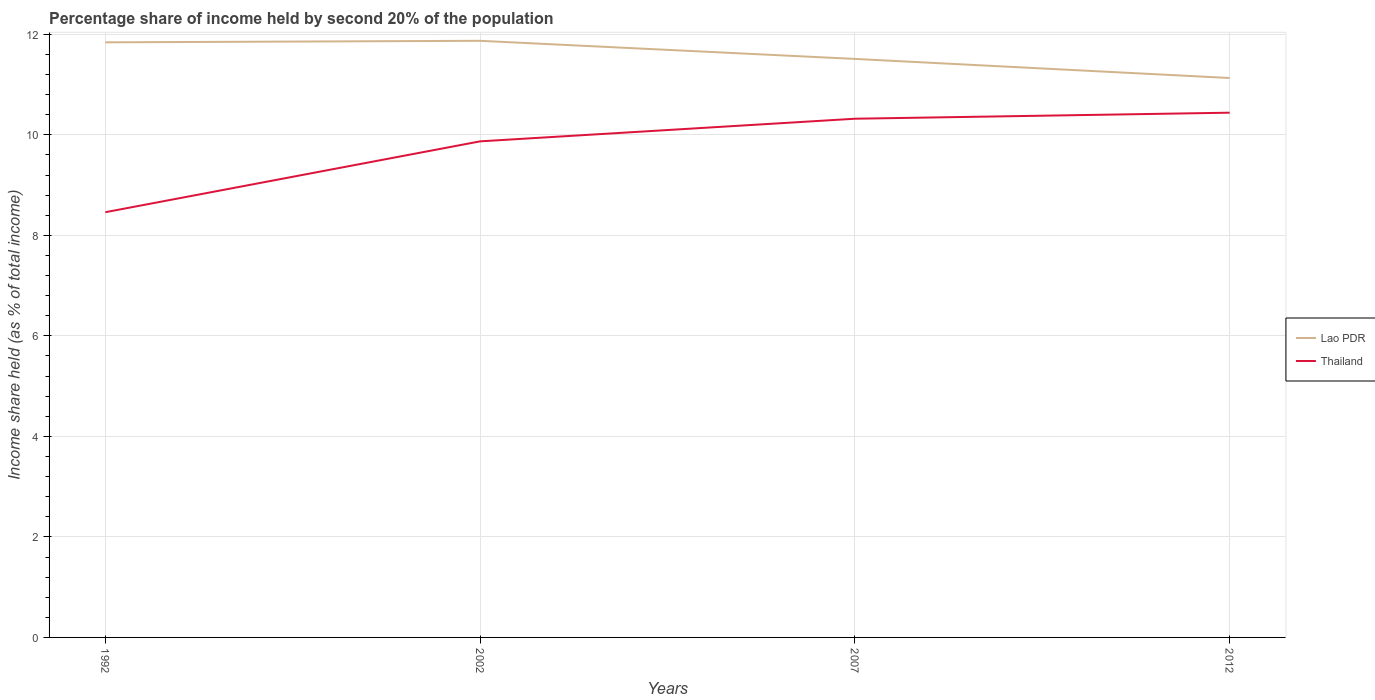How many different coloured lines are there?
Your answer should be very brief. 2. Across all years, what is the maximum share of income held by second 20% of the population in Thailand?
Provide a short and direct response. 8.46. What is the total share of income held by second 20% of the population in Lao PDR in the graph?
Provide a succinct answer. 0.38. What is the difference between the highest and the second highest share of income held by second 20% of the population in Lao PDR?
Keep it short and to the point. 0.74. What is the difference between the highest and the lowest share of income held by second 20% of the population in Thailand?
Provide a succinct answer. 3. Is the share of income held by second 20% of the population in Thailand strictly greater than the share of income held by second 20% of the population in Lao PDR over the years?
Make the answer very short. Yes. How many lines are there?
Your answer should be compact. 2. How many years are there in the graph?
Offer a terse response. 4. What is the difference between two consecutive major ticks on the Y-axis?
Provide a short and direct response. 2. Are the values on the major ticks of Y-axis written in scientific E-notation?
Make the answer very short. No. Where does the legend appear in the graph?
Provide a succinct answer. Center right. What is the title of the graph?
Offer a terse response. Percentage share of income held by second 20% of the population. Does "Montenegro" appear as one of the legend labels in the graph?
Provide a short and direct response. No. What is the label or title of the X-axis?
Give a very brief answer. Years. What is the label or title of the Y-axis?
Make the answer very short. Income share held (as % of total income). What is the Income share held (as % of total income) in Lao PDR in 1992?
Give a very brief answer. 11.84. What is the Income share held (as % of total income) of Thailand in 1992?
Provide a succinct answer. 8.46. What is the Income share held (as % of total income) of Lao PDR in 2002?
Ensure brevity in your answer.  11.87. What is the Income share held (as % of total income) of Thailand in 2002?
Your answer should be compact. 9.87. What is the Income share held (as % of total income) of Lao PDR in 2007?
Provide a short and direct response. 11.51. What is the Income share held (as % of total income) of Thailand in 2007?
Provide a short and direct response. 10.32. What is the Income share held (as % of total income) in Lao PDR in 2012?
Provide a succinct answer. 11.13. What is the Income share held (as % of total income) of Thailand in 2012?
Make the answer very short. 10.44. Across all years, what is the maximum Income share held (as % of total income) in Lao PDR?
Ensure brevity in your answer.  11.87. Across all years, what is the maximum Income share held (as % of total income) in Thailand?
Give a very brief answer. 10.44. Across all years, what is the minimum Income share held (as % of total income) of Lao PDR?
Your answer should be very brief. 11.13. Across all years, what is the minimum Income share held (as % of total income) in Thailand?
Make the answer very short. 8.46. What is the total Income share held (as % of total income) of Lao PDR in the graph?
Offer a terse response. 46.35. What is the total Income share held (as % of total income) in Thailand in the graph?
Make the answer very short. 39.09. What is the difference between the Income share held (as % of total income) in Lao PDR in 1992 and that in 2002?
Provide a succinct answer. -0.03. What is the difference between the Income share held (as % of total income) in Thailand in 1992 and that in 2002?
Give a very brief answer. -1.41. What is the difference between the Income share held (as % of total income) of Lao PDR in 1992 and that in 2007?
Give a very brief answer. 0.33. What is the difference between the Income share held (as % of total income) of Thailand in 1992 and that in 2007?
Your answer should be very brief. -1.86. What is the difference between the Income share held (as % of total income) of Lao PDR in 1992 and that in 2012?
Ensure brevity in your answer.  0.71. What is the difference between the Income share held (as % of total income) in Thailand in 1992 and that in 2012?
Offer a terse response. -1.98. What is the difference between the Income share held (as % of total income) in Lao PDR in 2002 and that in 2007?
Your answer should be very brief. 0.36. What is the difference between the Income share held (as % of total income) in Thailand in 2002 and that in 2007?
Give a very brief answer. -0.45. What is the difference between the Income share held (as % of total income) of Lao PDR in 2002 and that in 2012?
Ensure brevity in your answer.  0.74. What is the difference between the Income share held (as % of total income) of Thailand in 2002 and that in 2012?
Make the answer very short. -0.57. What is the difference between the Income share held (as % of total income) of Lao PDR in 2007 and that in 2012?
Your answer should be compact. 0.38. What is the difference between the Income share held (as % of total income) of Thailand in 2007 and that in 2012?
Your response must be concise. -0.12. What is the difference between the Income share held (as % of total income) of Lao PDR in 1992 and the Income share held (as % of total income) of Thailand in 2002?
Your answer should be compact. 1.97. What is the difference between the Income share held (as % of total income) of Lao PDR in 1992 and the Income share held (as % of total income) of Thailand in 2007?
Offer a very short reply. 1.52. What is the difference between the Income share held (as % of total income) of Lao PDR in 2002 and the Income share held (as % of total income) of Thailand in 2007?
Your response must be concise. 1.55. What is the difference between the Income share held (as % of total income) of Lao PDR in 2002 and the Income share held (as % of total income) of Thailand in 2012?
Provide a short and direct response. 1.43. What is the difference between the Income share held (as % of total income) of Lao PDR in 2007 and the Income share held (as % of total income) of Thailand in 2012?
Your answer should be compact. 1.07. What is the average Income share held (as % of total income) of Lao PDR per year?
Offer a very short reply. 11.59. What is the average Income share held (as % of total income) in Thailand per year?
Provide a succinct answer. 9.77. In the year 1992, what is the difference between the Income share held (as % of total income) in Lao PDR and Income share held (as % of total income) in Thailand?
Your response must be concise. 3.38. In the year 2007, what is the difference between the Income share held (as % of total income) in Lao PDR and Income share held (as % of total income) in Thailand?
Your response must be concise. 1.19. In the year 2012, what is the difference between the Income share held (as % of total income) in Lao PDR and Income share held (as % of total income) in Thailand?
Offer a very short reply. 0.69. What is the ratio of the Income share held (as % of total income) in Lao PDR in 1992 to that in 2002?
Your answer should be very brief. 1. What is the ratio of the Income share held (as % of total income) in Lao PDR in 1992 to that in 2007?
Ensure brevity in your answer.  1.03. What is the ratio of the Income share held (as % of total income) in Thailand in 1992 to that in 2007?
Keep it short and to the point. 0.82. What is the ratio of the Income share held (as % of total income) in Lao PDR in 1992 to that in 2012?
Your answer should be very brief. 1.06. What is the ratio of the Income share held (as % of total income) of Thailand in 1992 to that in 2012?
Keep it short and to the point. 0.81. What is the ratio of the Income share held (as % of total income) in Lao PDR in 2002 to that in 2007?
Keep it short and to the point. 1.03. What is the ratio of the Income share held (as % of total income) in Thailand in 2002 to that in 2007?
Offer a very short reply. 0.96. What is the ratio of the Income share held (as % of total income) of Lao PDR in 2002 to that in 2012?
Ensure brevity in your answer.  1.07. What is the ratio of the Income share held (as % of total income) in Thailand in 2002 to that in 2012?
Give a very brief answer. 0.95. What is the ratio of the Income share held (as % of total income) of Lao PDR in 2007 to that in 2012?
Give a very brief answer. 1.03. What is the ratio of the Income share held (as % of total income) in Thailand in 2007 to that in 2012?
Offer a very short reply. 0.99. What is the difference between the highest and the second highest Income share held (as % of total income) of Lao PDR?
Provide a succinct answer. 0.03. What is the difference between the highest and the second highest Income share held (as % of total income) of Thailand?
Give a very brief answer. 0.12. What is the difference between the highest and the lowest Income share held (as % of total income) of Lao PDR?
Offer a terse response. 0.74. What is the difference between the highest and the lowest Income share held (as % of total income) of Thailand?
Your answer should be compact. 1.98. 